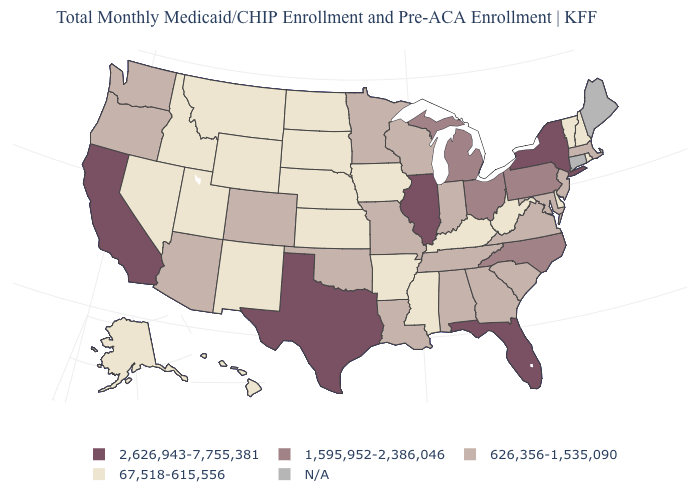What is the value of New Hampshire?
Short answer required. 67,518-615,556. Does the map have missing data?
Concise answer only. Yes. What is the value of Arizona?
Give a very brief answer. 626,356-1,535,090. Name the states that have a value in the range 626,356-1,535,090?
Be succinct. Alabama, Arizona, Colorado, Georgia, Indiana, Louisiana, Maryland, Massachusetts, Minnesota, Missouri, New Jersey, Oklahoma, Oregon, South Carolina, Tennessee, Virginia, Washington, Wisconsin. Name the states that have a value in the range 67,518-615,556?
Keep it brief. Alaska, Arkansas, Delaware, Hawaii, Idaho, Iowa, Kansas, Kentucky, Mississippi, Montana, Nebraska, Nevada, New Hampshire, New Mexico, North Dakota, Rhode Island, South Dakota, Utah, Vermont, West Virginia, Wyoming. Name the states that have a value in the range 67,518-615,556?
Give a very brief answer. Alaska, Arkansas, Delaware, Hawaii, Idaho, Iowa, Kansas, Kentucky, Mississippi, Montana, Nebraska, Nevada, New Hampshire, New Mexico, North Dakota, Rhode Island, South Dakota, Utah, Vermont, West Virginia, Wyoming. What is the value of Utah?
Quick response, please. 67,518-615,556. What is the value of Florida?
Quick response, please. 2,626,943-7,755,381. What is the lowest value in the USA?
Answer briefly. 67,518-615,556. What is the lowest value in the West?
Keep it brief. 67,518-615,556. What is the highest value in states that border Arkansas?
Concise answer only. 2,626,943-7,755,381. What is the highest value in the USA?
Quick response, please. 2,626,943-7,755,381. What is the value of Alabama?
Short answer required. 626,356-1,535,090. Which states hav the highest value in the MidWest?
Give a very brief answer. Illinois. 